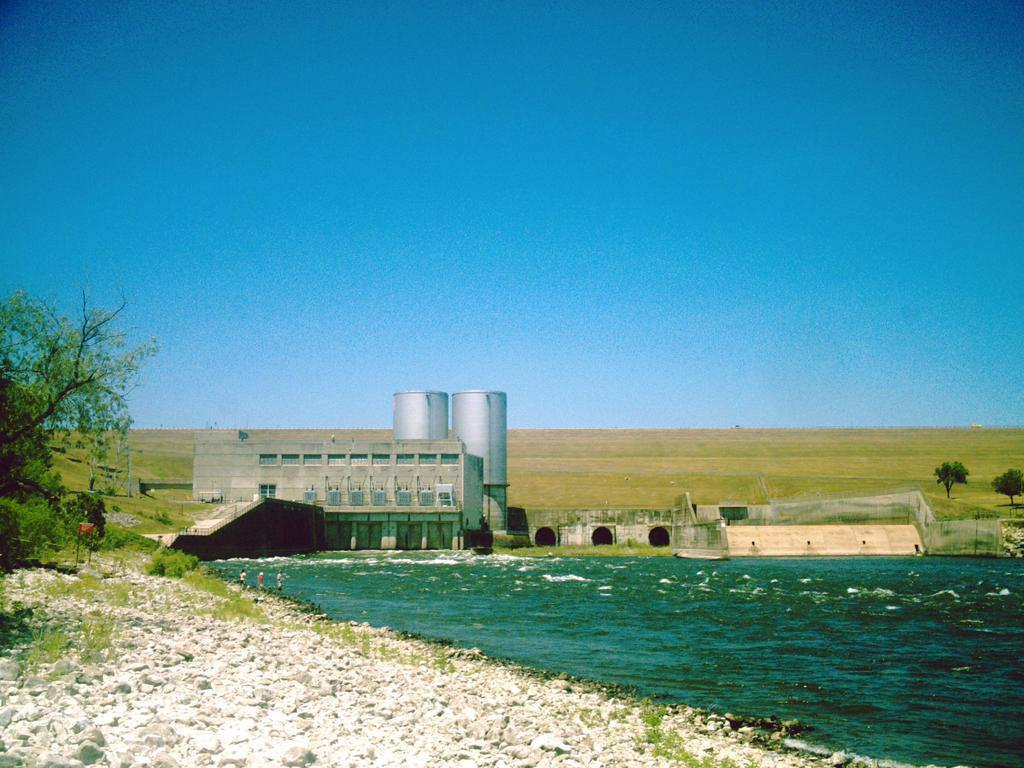What can be seen at the top of the image? The sky is visible in the image. What body of water is present in the image? There is a lake in the image. What type of vehicles are in front of the lake? Tankers are present in front of the lake. What type of vegetation is visible on the left side of the image? There is a tree visible on the left side of the image. How many rabbits can be seen hopping around the tree in the image? There are no rabbits present in the image; it features a tree and a lake with tankers. What type of iron is being used to construct the tankers in the image? There is no indication of the type of iron used in the construction of the tankers in the image. 